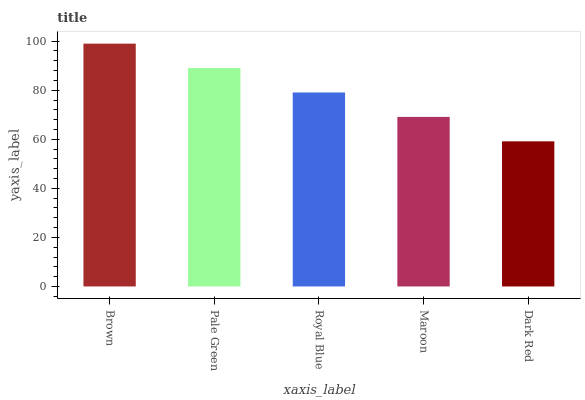Is Dark Red the minimum?
Answer yes or no. Yes. Is Brown the maximum?
Answer yes or no. Yes. Is Pale Green the minimum?
Answer yes or no. No. Is Pale Green the maximum?
Answer yes or no. No. Is Brown greater than Pale Green?
Answer yes or no. Yes. Is Pale Green less than Brown?
Answer yes or no. Yes. Is Pale Green greater than Brown?
Answer yes or no. No. Is Brown less than Pale Green?
Answer yes or no. No. Is Royal Blue the high median?
Answer yes or no. Yes. Is Royal Blue the low median?
Answer yes or no. Yes. Is Pale Green the high median?
Answer yes or no. No. Is Pale Green the low median?
Answer yes or no. No. 